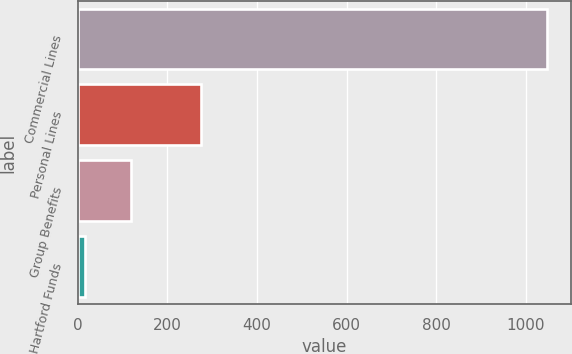Convert chart to OTSL. <chart><loc_0><loc_0><loc_500><loc_500><bar_chart><fcel>Commercial Lines<fcel>Personal Lines<fcel>Group Benefits<fcel>Hartford Funds<nl><fcel>1048<fcel>275<fcel>119.2<fcel>16<nl></chart> 